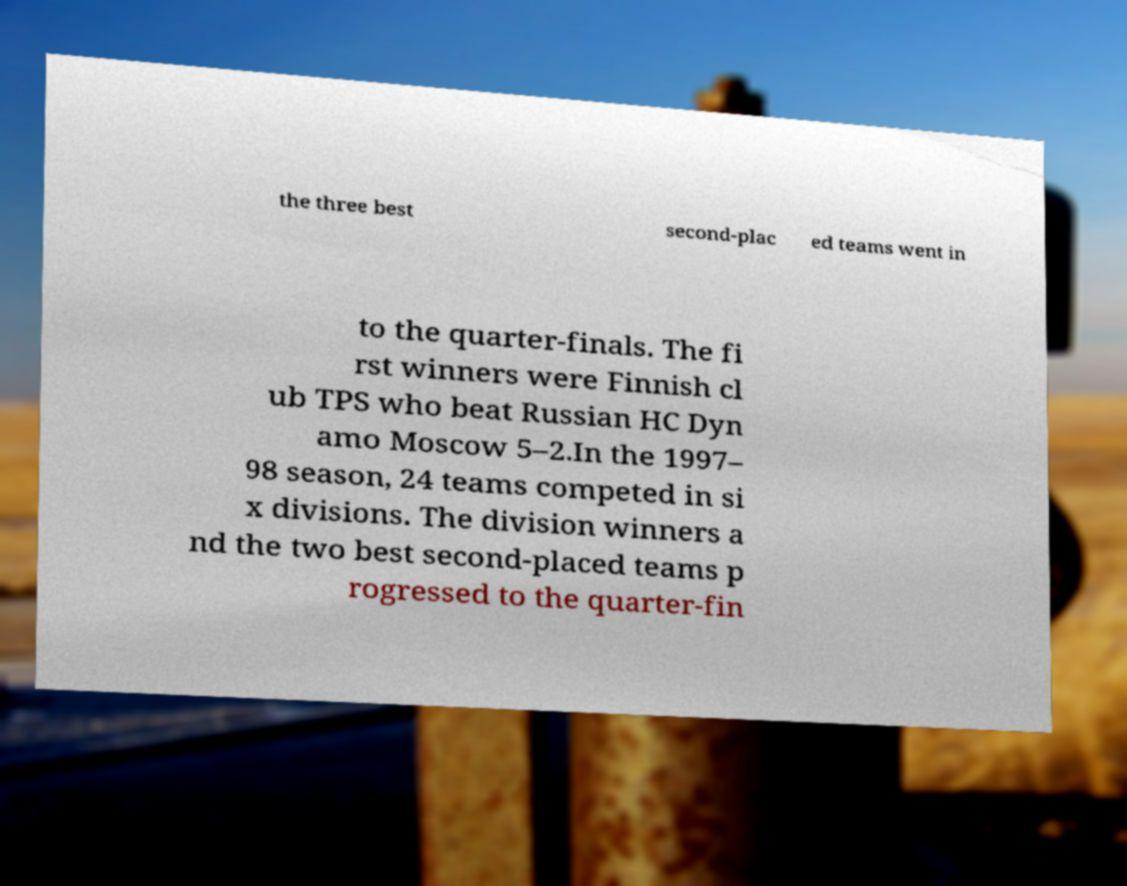I need the written content from this picture converted into text. Can you do that? the three best second-plac ed teams went in to the quarter-finals. The fi rst winners were Finnish cl ub TPS who beat Russian HC Dyn amo Moscow 5–2.In the 1997– 98 season, 24 teams competed in si x divisions. The division winners a nd the two best second-placed teams p rogressed to the quarter-fin 